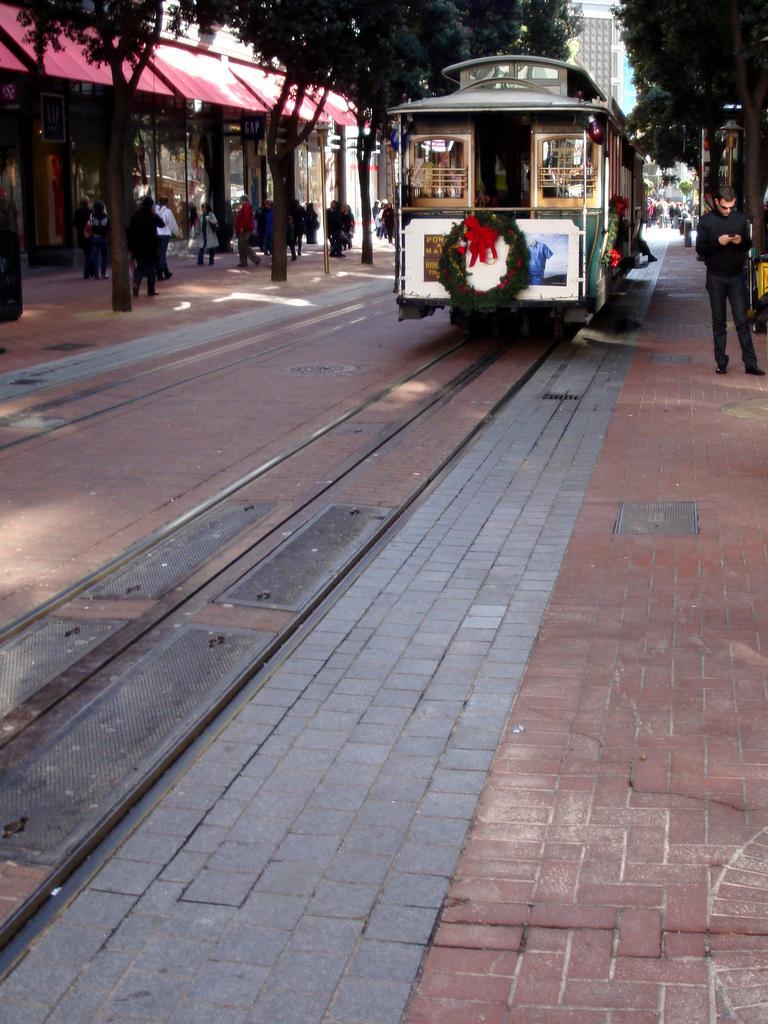How would you summarize this image in a sentence or two? In this image I can see train on a railway track. Here I can see people are standing. In the background I can see trees and buildings. 